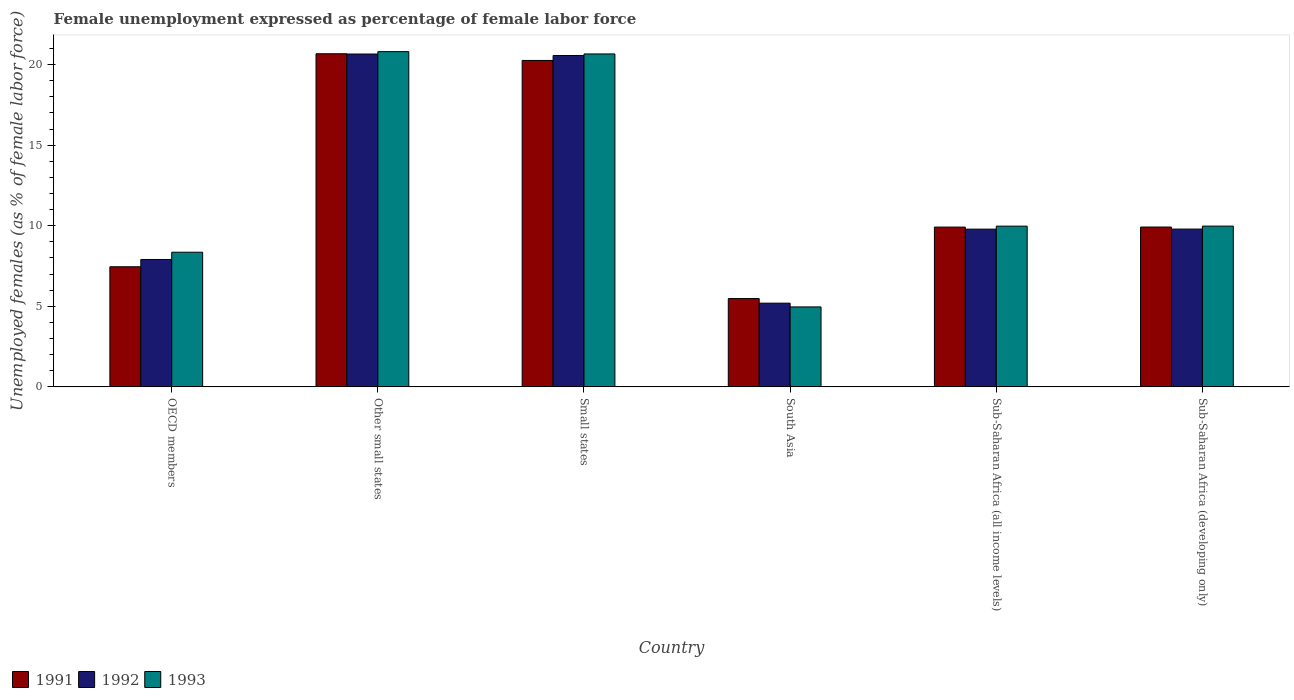How many different coloured bars are there?
Your answer should be very brief. 3. Are the number of bars on each tick of the X-axis equal?
Offer a terse response. Yes. How many bars are there on the 3rd tick from the left?
Provide a succinct answer. 3. How many bars are there on the 5th tick from the right?
Offer a terse response. 3. What is the label of the 4th group of bars from the left?
Ensure brevity in your answer.  South Asia. In how many cases, is the number of bars for a given country not equal to the number of legend labels?
Make the answer very short. 0. What is the unemployment in females in in 1991 in Sub-Saharan Africa (all income levels)?
Ensure brevity in your answer.  9.91. Across all countries, what is the maximum unemployment in females in in 1992?
Offer a terse response. 20.65. Across all countries, what is the minimum unemployment in females in in 1992?
Provide a short and direct response. 5.19. In which country was the unemployment in females in in 1992 maximum?
Your answer should be compact. Other small states. In which country was the unemployment in females in in 1993 minimum?
Provide a short and direct response. South Asia. What is the total unemployment in females in in 1992 in the graph?
Provide a succinct answer. 73.89. What is the difference between the unemployment in females in in 1993 in OECD members and that in Sub-Saharan Africa (developing only)?
Your response must be concise. -1.62. What is the difference between the unemployment in females in in 1992 in Small states and the unemployment in females in in 1993 in Sub-Saharan Africa (developing only)?
Offer a terse response. 10.58. What is the average unemployment in females in in 1991 per country?
Make the answer very short. 12.28. What is the difference between the unemployment in females in of/in 1991 and unemployment in females in of/in 1993 in Sub-Saharan Africa (all income levels)?
Offer a terse response. -0.06. What is the ratio of the unemployment in females in in 1991 in South Asia to that in Sub-Saharan Africa (developing only)?
Give a very brief answer. 0.55. What is the difference between the highest and the second highest unemployment in females in in 1992?
Your answer should be very brief. -10.86. What is the difference between the highest and the lowest unemployment in females in in 1991?
Ensure brevity in your answer.  15.19. In how many countries, is the unemployment in females in in 1991 greater than the average unemployment in females in in 1991 taken over all countries?
Keep it short and to the point. 2. What does the 1st bar from the right in OECD members represents?
Provide a short and direct response. 1993. Is it the case that in every country, the sum of the unemployment in females in in 1992 and unemployment in females in in 1993 is greater than the unemployment in females in in 1991?
Ensure brevity in your answer.  Yes. How many bars are there?
Give a very brief answer. 18. How many countries are there in the graph?
Ensure brevity in your answer.  6. Are the values on the major ticks of Y-axis written in scientific E-notation?
Make the answer very short. No. Does the graph contain any zero values?
Provide a short and direct response. No. Does the graph contain grids?
Provide a succinct answer. No. Where does the legend appear in the graph?
Keep it short and to the point. Bottom left. How many legend labels are there?
Offer a terse response. 3. How are the legend labels stacked?
Your answer should be very brief. Horizontal. What is the title of the graph?
Ensure brevity in your answer.  Female unemployment expressed as percentage of female labor force. What is the label or title of the X-axis?
Offer a terse response. Country. What is the label or title of the Y-axis?
Your response must be concise. Unemployed females (as % of female labor force). What is the Unemployed females (as % of female labor force) of 1991 in OECD members?
Offer a very short reply. 7.45. What is the Unemployed females (as % of female labor force) of 1992 in OECD members?
Make the answer very short. 7.9. What is the Unemployed females (as % of female labor force) in 1993 in OECD members?
Your answer should be compact. 8.35. What is the Unemployed females (as % of female labor force) of 1991 in Other small states?
Provide a short and direct response. 20.67. What is the Unemployed females (as % of female labor force) in 1992 in Other small states?
Make the answer very short. 20.65. What is the Unemployed females (as % of female labor force) in 1993 in Other small states?
Your answer should be compact. 20.8. What is the Unemployed females (as % of female labor force) of 1991 in Small states?
Ensure brevity in your answer.  20.25. What is the Unemployed females (as % of female labor force) in 1992 in Small states?
Keep it short and to the point. 20.56. What is the Unemployed females (as % of female labor force) in 1993 in Small states?
Your response must be concise. 20.66. What is the Unemployed females (as % of female labor force) in 1991 in South Asia?
Keep it short and to the point. 5.48. What is the Unemployed females (as % of female labor force) in 1992 in South Asia?
Your answer should be compact. 5.19. What is the Unemployed females (as % of female labor force) of 1993 in South Asia?
Your answer should be compact. 4.96. What is the Unemployed females (as % of female labor force) in 1991 in Sub-Saharan Africa (all income levels)?
Your response must be concise. 9.91. What is the Unemployed females (as % of female labor force) in 1992 in Sub-Saharan Africa (all income levels)?
Offer a terse response. 9.79. What is the Unemployed females (as % of female labor force) of 1993 in Sub-Saharan Africa (all income levels)?
Ensure brevity in your answer.  9.97. What is the Unemployed females (as % of female labor force) of 1991 in Sub-Saharan Africa (developing only)?
Make the answer very short. 9.92. What is the Unemployed females (as % of female labor force) in 1992 in Sub-Saharan Africa (developing only)?
Provide a succinct answer. 9.79. What is the Unemployed females (as % of female labor force) of 1993 in Sub-Saharan Africa (developing only)?
Keep it short and to the point. 9.98. Across all countries, what is the maximum Unemployed females (as % of female labor force) of 1991?
Provide a succinct answer. 20.67. Across all countries, what is the maximum Unemployed females (as % of female labor force) in 1992?
Give a very brief answer. 20.65. Across all countries, what is the maximum Unemployed females (as % of female labor force) of 1993?
Your answer should be compact. 20.8. Across all countries, what is the minimum Unemployed females (as % of female labor force) in 1991?
Offer a very short reply. 5.48. Across all countries, what is the minimum Unemployed females (as % of female labor force) of 1992?
Provide a succinct answer. 5.19. Across all countries, what is the minimum Unemployed females (as % of female labor force) in 1993?
Offer a very short reply. 4.96. What is the total Unemployed females (as % of female labor force) of 1991 in the graph?
Give a very brief answer. 73.69. What is the total Unemployed females (as % of female labor force) in 1992 in the graph?
Your answer should be compact. 73.89. What is the total Unemployed females (as % of female labor force) of 1993 in the graph?
Ensure brevity in your answer.  74.72. What is the difference between the Unemployed females (as % of female labor force) of 1991 in OECD members and that in Other small states?
Your response must be concise. -13.22. What is the difference between the Unemployed females (as % of female labor force) of 1992 in OECD members and that in Other small states?
Offer a very short reply. -12.75. What is the difference between the Unemployed females (as % of female labor force) in 1993 in OECD members and that in Other small states?
Your answer should be very brief. -12.45. What is the difference between the Unemployed females (as % of female labor force) of 1991 in OECD members and that in Small states?
Provide a succinct answer. -12.8. What is the difference between the Unemployed females (as % of female labor force) of 1992 in OECD members and that in Small states?
Your response must be concise. -12.66. What is the difference between the Unemployed females (as % of female labor force) in 1993 in OECD members and that in Small states?
Make the answer very short. -12.3. What is the difference between the Unemployed females (as % of female labor force) of 1991 in OECD members and that in South Asia?
Make the answer very short. 1.97. What is the difference between the Unemployed females (as % of female labor force) in 1992 in OECD members and that in South Asia?
Offer a very short reply. 2.71. What is the difference between the Unemployed females (as % of female labor force) in 1993 in OECD members and that in South Asia?
Your answer should be compact. 3.39. What is the difference between the Unemployed females (as % of female labor force) in 1991 in OECD members and that in Sub-Saharan Africa (all income levels)?
Your answer should be compact. -2.46. What is the difference between the Unemployed females (as % of female labor force) of 1992 in OECD members and that in Sub-Saharan Africa (all income levels)?
Give a very brief answer. -1.88. What is the difference between the Unemployed females (as % of female labor force) of 1993 in OECD members and that in Sub-Saharan Africa (all income levels)?
Offer a very short reply. -1.62. What is the difference between the Unemployed females (as % of female labor force) in 1991 in OECD members and that in Sub-Saharan Africa (developing only)?
Offer a very short reply. -2.47. What is the difference between the Unemployed females (as % of female labor force) in 1992 in OECD members and that in Sub-Saharan Africa (developing only)?
Make the answer very short. -1.89. What is the difference between the Unemployed females (as % of female labor force) in 1993 in OECD members and that in Sub-Saharan Africa (developing only)?
Offer a terse response. -1.62. What is the difference between the Unemployed females (as % of female labor force) of 1991 in Other small states and that in Small states?
Give a very brief answer. 0.41. What is the difference between the Unemployed females (as % of female labor force) in 1992 in Other small states and that in Small states?
Your answer should be very brief. 0.09. What is the difference between the Unemployed females (as % of female labor force) in 1993 in Other small states and that in Small states?
Provide a succinct answer. 0.14. What is the difference between the Unemployed females (as % of female labor force) in 1991 in Other small states and that in South Asia?
Make the answer very short. 15.19. What is the difference between the Unemployed females (as % of female labor force) of 1992 in Other small states and that in South Asia?
Offer a terse response. 15.46. What is the difference between the Unemployed females (as % of female labor force) of 1993 in Other small states and that in South Asia?
Ensure brevity in your answer.  15.84. What is the difference between the Unemployed females (as % of female labor force) of 1991 in Other small states and that in Sub-Saharan Africa (all income levels)?
Offer a very short reply. 10.75. What is the difference between the Unemployed females (as % of female labor force) of 1992 in Other small states and that in Sub-Saharan Africa (all income levels)?
Ensure brevity in your answer.  10.87. What is the difference between the Unemployed females (as % of female labor force) of 1993 in Other small states and that in Sub-Saharan Africa (all income levels)?
Offer a terse response. 10.83. What is the difference between the Unemployed females (as % of female labor force) in 1991 in Other small states and that in Sub-Saharan Africa (developing only)?
Offer a terse response. 10.75. What is the difference between the Unemployed females (as % of female labor force) of 1992 in Other small states and that in Sub-Saharan Africa (developing only)?
Give a very brief answer. 10.86. What is the difference between the Unemployed females (as % of female labor force) of 1993 in Other small states and that in Sub-Saharan Africa (developing only)?
Ensure brevity in your answer.  10.83. What is the difference between the Unemployed females (as % of female labor force) of 1991 in Small states and that in South Asia?
Offer a terse response. 14.77. What is the difference between the Unemployed females (as % of female labor force) in 1992 in Small states and that in South Asia?
Offer a terse response. 15.37. What is the difference between the Unemployed females (as % of female labor force) of 1993 in Small states and that in South Asia?
Your answer should be very brief. 15.7. What is the difference between the Unemployed females (as % of female labor force) in 1991 in Small states and that in Sub-Saharan Africa (all income levels)?
Provide a succinct answer. 10.34. What is the difference between the Unemployed females (as % of female labor force) of 1992 in Small states and that in Sub-Saharan Africa (all income levels)?
Offer a very short reply. 10.77. What is the difference between the Unemployed females (as % of female labor force) of 1993 in Small states and that in Sub-Saharan Africa (all income levels)?
Provide a short and direct response. 10.69. What is the difference between the Unemployed females (as % of female labor force) in 1991 in Small states and that in Sub-Saharan Africa (developing only)?
Keep it short and to the point. 10.34. What is the difference between the Unemployed females (as % of female labor force) of 1992 in Small states and that in Sub-Saharan Africa (developing only)?
Your answer should be compact. 10.77. What is the difference between the Unemployed females (as % of female labor force) of 1993 in Small states and that in Sub-Saharan Africa (developing only)?
Offer a terse response. 10.68. What is the difference between the Unemployed females (as % of female labor force) of 1991 in South Asia and that in Sub-Saharan Africa (all income levels)?
Provide a short and direct response. -4.43. What is the difference between the Unemployed females (as % of female labor force) of 1992 in South Asia and that in Sub-Saharan Africa (all income levels)?
Your answer should be very brief. -4.59. What is the difference between the Unemployed females (as % of female labor force) in 1993 in South Asia and that in Sub-Saharan Africa (all income levels)?
Your response must be concise. -5.01. What is the difference between the Unemployed females (as % of female labor force) of 1991 in South Asia and that in Sub-Saharan Africa (developing only)?
Offer a terse response. -4.44. What is the difference between the Unemployed females (as % of female labor force) in 1992 in South Asia and that in Sub-Saharan Africa (developing only)?
Your answer should be compact. -4.6. What is the difference between the Unemployed females (as % of female labor force) of 1993 in South Asia and that in Sub-Saharan Africa (developing only)?
Give a very brief answer. -5.01. What is the difference between the Unemployed females (as % of female labor force) in 1991 in Sub-Saharan Africa (all income levels) and that in Sub-Saharan Africa (developing only)?
Your answer should be very brief. -0. What is the difference between the Unemployed females (as % of female labor force) of 1992 in Sub-Saharan Africa (all income levels) and that in Sub-Saharan Africa (developing only)?
Keep it short and to the point. -0. What is the difference between the Unemployed females (as % of female labor force) of 1993 in Sub-Saharan Africa (all income levels) and that in Sub-Saharan Africa (developing only)?
Give a very brief answer. -0. What is the difference between the Unemployed females (as % of female labor force) in 1991 in OECD members and the Unemployed females (as % of female labor force) in 1992 in Other small states?
Ensure brevity in your answer.  -13.2. What is the difference between the Unemployed females (as % of female labor force) in 1991 in OECD members and the Unemployed females (as % of female labor force) in 1993 in Other small states?
Offer a terse response. -13.35. What is the difference between the Unemployed females (as % of female labor force) of 1992 in OECD members and the Unemployed females (as % of female labor force) of 1993 in Other small states?
Offer a terse response. -12.9. What is the difference between the Unemployed females (as % of female labor force) of 1991 in OECD members and the Unemployed females (as % of female labor force) of 1992 in Small states?
Provide a succinct answer. -13.11. What is the difference between the Unemployed females (as % of female labor force) in 1991 in OECD members and the Unemployed females (as % of female labor force) in 1993 in Small states?
Provide a short and direct response. -13.21. What is the difference between the Unemployed females (as % of female labor force) in 1992 in OECD members and the Unemployed females (as % of female labor force) in 1993 in Small states?
Ensure brevity in your answer.  -12.75. What is the difference between the Unemployed females (as % of female labor force) in 1991 in OECD members and the Unemployed females (as % of female labor force) in 1992 in South Asia?
Offer a very short reply. 2.26. What is the difference between the Unemployed females (as % of female labor force) of 1991 in OECD members and the Unemployed females (as % of female labor force) of 1993 in South Asia?
Provide a succinct answer. 2.49. What is the difference between the Unemployed females (as % of female labor force) of 1992 in OECD members and the Unemployed females (as % of female labor force) of 1993 in South Asia?
Your answer should be compact. 2.94. What is the difference between the Unemployed females (as % of female labor force) in 1991 in OECD members and the Unemployed females (as % of female labor force) in 1992 in Sub-Saharan Africa (all income levels)?
Provide a short and direct response. -2.34. What is the difference between the Unemployed females (as % of female labor force) in 1991 in OECD members and the Unemployed females (as % of female labor force) in 1993 in Sub-Saharan Africa (all income levels)?
Offer a terse response. -2.52. What is the difference between the Unemployed females (as % of female labor force) in 1992 in OECD members and the Unemployed females (as % of female labor force) in 1993 in Sub-Saharan Africa (all income levels)?
Your answer should be very brief. -2.07. What is the difference between the Unemployed females (as % of female labor force) of 1991 in OECD members and the Unemployed females (as % of female labor force) of 1992 in Sub-Saharan Africa (developing only)?
Keep it short and to the point. -2.34. What is the difference between the Unemployed females (as % of female labor force) of 1991 in OECD members and the Unemployed females (as % of female labor force) of 1993 in Sub-Saharan Africa (developing only)?
Give a very brief answer. -2.52. What is the difference between the Unemployed females (as % of female labor force) in 1992 in OECD members and the Unemployed females (as % of female labor force) in 1993 in Sub-Saharan Africa (developing only)?
Provide a succinct answer. -2.07. What is the difference between the Unemployed females (as % of female labor force) of 1991 in Other small states and the Unemployed females (as % of female labor force) of 1992 in Small states?
Ensure brevity in your answer.  0.11. What is the difference between the Unemployed females (as % of female labor force) in 1991 in Other small states and the Unemployed females (as % of female labor force) in 1993 in Small states?
Ensure brevity in your answer.  0.01. What is the difference between the Unemployed females (as % of female labor force) of 1992 in Other small states and the Unemployed females (as % of female labor force) of 1993 in Small states?
Provide a succinct answer. -0.01. What is the difference between the Unemployed females (as % of female labor force) of 1991 in Other small states and the Unemployed females (as % of female labor force) of 1992 in South Asia?
Ensure brevity in your answer.  15.47. What is the difference between the Unemployed females (as % of female labor force) in 1991 in Other small states and the Unemployed females (as % of female labor force) in 1993 in South Asia?
Provide a succinct answer. 15.71. What is the difference between the Unemployed females (as % of female labor force) in 1992 in Other small states and the Unemployed females (as % of female labor force) in 1993 in South Asia?
Give a very brief answer. 15.69. What is the difference between the Unemployed females (as % of female labor force) in 1991 in Other small states and the Unemployed females (as % of female labor force) in 1992 in Sub-Saharan Africa (all income levels)?
Make the answer very short. 10.88. What is the difference between the Unemployed females (as % of female labor force) in 1991 in Other small states and the Unemployed females (as % of female labor force) in 1993 in Sub-Saharan Africa (all income levels)?
Your answer should be compact. 10.7. What is the difference between the Unemployed females (as % of female labor force) of 1992 in Other small states and the Unemployed females (as % of female labor force) of 1993 in Sub-Saharan Africa (all income levels)?
Your answer should be compact. 10.68. What is the difference between the Unemployed females (as % of female labor force) in 1991 in Other small states and the Unemployed females (as % of female labor force) in 1992 in Sub-Saharan Africa (developing only)?
Make the answer very short. 10.88. What is the difference between the Unemployed females (as % of female labor force) of 1991 in Other small states and the Unemployed females (as % of female labor force) of 1993 in Sub-Saharan Africa (developing only)?
Keep it short and to the point. 10.69. What is the difference between the Unemployed females (as % of female labor force) in 1992 in Other small states and the Unemployed females (as % of female labor force) in 1993 in Sub-Saharan Africa (developing only)?
Keep it short and to the point. 10.68. What is the difference between the Unemployed females (as % of female labor force) of 1991 in Small states and the Unemployed females (as % of female labor force) of 1992 in South Asia?
Your answer should be compact. 15.06. What is the difference between the Unemployed females (as % of female labor force) of 1991 in Small states and the Unemployed females (as % of female labor force) of 1993 in South Asia?
Give a very brief answer. 15.29. What is the difference between the Unemployed females (as % of female labor force) of 1992 in Small states and the Unemployed females (as % of female labor force) of 1993 in South Asia?
Make the answer very short. 15.6. What is the difference between the Unemployed females (as % of female labor force) of 1991 in Small states and the Unemployed females (as % of female labor force) of 1992 in Sub-Saharan Africa (all income levels)?
Your answer should be compact. 10.47. What is the difference between the Unemployed females (as % of female labor force) of 1991 in Small states and the Unemployed females (as % of female labor force) of 1993 in Sub-Saharan Africa (all income levels)?
Your answer should be compact. 10.28. What is the difference between the Unemployed females (as % of female labor force) of 1992 in Small states and the Unemployed females (as % of female labor force) of 1993 in Sub-Saharan Africa (all income levels)?
Your answer should be compact. 10.59. What is the difference between the Unemployed females (as % of female labor force) of 1991 in Small states and the Unemployed females (as % of female labor force) of 1992 in Sub-Saharan Africa (developing only)?
Provide a succinct answer. 10.46. What is the difference between the Unemployed females (as % of female labor force) of 1991 in Small states and the Unemployed females (as % of female labor force) of 1993 in Sub-Saharan Africa (developing only)?
Give a very brief answer. 10.28. What is the difference between the Unemployed females (as % of female labor force) in 1992 in Small states and the Unemployed females (as % of female labor force) in 1993 in Sub-Saharan Africa (developing only)?
Offer a terse response. 10.58. What is the difference between the Unemployed females (as % of female labor force) of 1991 in South Asia and the Unemployed females (as % of female labor force) of 1992 in Sub-Saharan Africa (all income levels)?
Keep it short and to the point. -4.31. What is the difference between the Unemployed females (as % of female labor force) of 1991 in South Asia and the Unemployed females (as % of female labor force) of 1993 in Sub-Saharan Africa (all income levels)?
Offer a terse response. -4.49. What is the difference between the Unemployed females (as % of female labor force) in 1992 in South Asia and the Unemployed females (as % of female labor force) in 1993 in Sub-Saharan Africa (all income levels)?
Provide a succinct answer. -4.78. What is the difference between the Unemployed females (as % of female labor force) of 1991 in South Asia and the Unemployed females (as % of female labor force) of 1992 in Sub-Saharan Africa (developing only)?
Your answer should be very brief. -4.31. What is the difference between the Unemployed females (as % of female labor force) in 1991 in South Asia and the Unemployed females (as % of female labor force) in 1993 in Sub-Saharan Africa (developing only)?
Ensure brevity in your answer.  -4.5. What is the difference between the Unemployed females (as % of female labor force) of 1992 in South Asia and the Unemployed females (as % of female labor force) of 1993 in Sub-Saharan Africa (developing only)?
Offer a terse response. -4.78. What is the difference between the Unemployed females (as % of female labor force) of 1991 in Sub-Saharan Africa (all income levels) and the Unemployed females (as % of female labor force) of 1992 in Sub-Saharan Africa (developing only)?
Provide a short and direct response. 0.12. What is the difference between the Unemployed females (as % of female labor force) in 1991 in Sub-Saharan Africa (all income levels) and the Unemployed females (as % of female labor force) in 1993 in Sub-Saharan Africa (developing only)?
Keep it short and to the point. -0.06. What is the difference between the Unemployed females (as % of female labor force) of 1992 in Sub-Saharan Africa (all income levels) and the Unemployed females (as % of female labor force) of 1993 in Sub-Saharan Africa (developing only)?
Your answer should be very brief. -0.19. What is the average Unemployed females (as % of female labor force) of 1991 per country?
Your response must be concise. 12.28. What is the average Unemployed females (as % of female labor force) in 1992 per country?
Give a very brief answer. 12.31. What is the average Unemployed females (as % of female labor force) of 1993 per country?
Your answer should be compact. 12.45. What is the difference between the Unemployed females (as % of female labor force) of 1991 and Unemployed females (as % of female labor force) of 1992 in OECD members?
Provide a short and direct response. -0.45. What is the difference between the Unemployed females (as % of female labor force) of 1991 and Unemployed females (as % of female labor force) of 1993 in OECD members?
Offer a very short reply. -0.9. What is the difference between the Unemployed females (as % of female labor force) in 1992 and Unemployed females (as % of female labor force) in 1993 in OECD members?
Offer a terse response. -0.45. What is the difference between the Unemployed females (as % of female labor force) of 1991 and Unemployed females (as % of female labor force) of 1992 in Other small states?
Offer a terse response. 0.02. What is the difference between the Unemployed females (as % of female labor force) of 1991 and Unemployed females (as % of female labor force) of 1993 in Other small states?
Ensure brevity in your answer.  -0.13. What is the difference between the Unemployed females (as % of female labor force) of 1992 and Unemployed females (as % of female labor force) of 1993 in Other small states?
Give a very brief answer. -0.15. What is the difference between the Unemployed females (as % of female labor force) of 1991 and Unemployed females (as % of female labor force) of 1992 in Small states?
Make the answer very short. -0.31. What is the difference between the Unemployed females (as % of female labor force) in 1991 and Unemployed females (as % of female labor force) in 1993 in Small states?
Make the answer very short. -0.4. What is the difference between the Unemployed females (as % of female labor force) of 1992 and Unemployed females (as % of female labor force) of 1993 in Small states?
Offer a very short reply. -0.1. What is the difference between the Unemployed females (as % of female labor force) in 1991 and Unemployed females (as % of female labor force) in 1992 in South Asia?
Your answer should be compact. 0.29. What is the difference between the Unemployed females (as % of female labor force) of 1991 and Unemployed females (as % of female labor force) of 1993 in South Asia?
Give a very brief answer. 0.52. What is the difference between the Unemployed females (as % of female labor force) of 1992 and Unemployed females (as % of female labor force) of 1993 in South Asia?
Keep it short and to the point. 0.23. What is the difference between the Unemployed females (as % of female labor force) of 1991 and Unemployed females (as % of female labor force) of 1992 in Sub-Saharan Africa (all income levels)?
Provide a short and direct response. 0.13. What is the difference between the Unemployed females (as % of female labor force) of 1991 and Unemployed females (as % of female labor force) of 1993 in Sub-Saharan Africa (all income levels)?
Offer a very short reply. -0.06. What is the difference between the Unemployed females (as % of female labor force) in 1992 and Unemployed females (as % of female labor force) in 1993 in Sub-Saharan Africa (all income levels)?
Keep it short and to the point. -0.18. What is the difference between the Unemployed females (as % of female labor force) in 1991 and Unemployed females (as % of female labor force) in 1992 in Sub-Saharan Africa (developing only)?
Your answer should be compact. 0.13. What is the difference between the Unemployed females (as % of female labor force) of 1991 and Unemployed females (as % of female labor force) of 1993 in Sub-Saharan Africa (developing only)?
Your answer should be very brief. -0.06. What is the difference between the Unemployed females (as % of female labor force) of 1992 and Unemployed females (as % of female labor force) of 1993 in Sub-Saharan Africa (developing only)?
Provide a succinct answer. -0.18. What is the ratio of the Unemployed females (as % of female labor force) of 1991 in OECD members to that in Other small states?
Your answer should be very brief. 0.36. What is the ratio of the Unemployed females (as % of female labor force) of 1992 in OECD members to that in Other small states?
Make the answer very short. 0.38. What is the ratio of the Unemployed females (as % of female labor force) in 1993 in OECD members to that in Other small states?
Keep it short and to the point. 0.4. What is the ratio of the Unemployed females (as % of female labor force) in 1991 in OECD members to that in Small states?
Keep it short and to the point. 0.37. What is the ratio of the Unemployed females (as % of female labor force) of 1992 in OECD members to that in Small states?
Provide a short and direct response. 0.38. What is the ratio of the Unemployed females (as % of female labor force) in 1993 in OECD members to that in Small states?
Make the answer very short. 0.4. What is the ratio of the Unemployed females (as % of female labor force) of 1991 in OECD members to that in South Asia?
Keep it short and to the point. 1.36. What is the ratio of the Unemployed females (as % of female labor force) of 1992 in OECD members to that in South Asia?
Give a very brief answer. 1.52. What is the ratio of the Unemployed females (as % of female labor force) of 1993 in OECD members to that in South Asia?
Provide a succinct answer. 1.68. What is the ratio of the Unemployed females (as % of female labor force) of 1991 in OECD members to that in Sub-Saharan Africa (all income levels)?
Provide a succinct answer. 0.75. What is the ratio of the Unemployed females (as % of female labor force) of 1992 in OECD members to that in Sub-Saharan Africa (all income levels)?
Keep it short and to the point. 0.81. What is the ratio of the Unemployed females (as % of female labor force) in 1993 in OECD members to that in Sub-Saharan Africa (all income levels)?
Your answer should be very brief. 0.84. What is the ratio of the Unemployed females (as % of female labor force) in 1991 in OECD members to that in Sub-Saharan Africa (developing only)?
Keep it short and to the point. 0.75. What is the ratio of the Unemployed females (as % of female labor force) in 1992 in OECD members to that in Sub-Saharan Africa (developing only)?
Your response must be concise. 0.81. What is the ratio of the Unemployed females (as % of female labor force) in 1993 in OECD members to that in Sub-Saharan Africa (developing only)?
Offer a very short reply. 0.84. What is the ratio of the Unemployed females (as % of female labor force) in 1991 in Other small states to that in Small states?
Offer a very short reply. 1.02. What is the ratio of the Unemployed females (as % of female labor force) in 1993 in Other small states to that in Small states?
Provide a succinct answer. 1.01. What is the ratio of the Unemployed females (as % of female labor force) of 1991 in Other small states to that in South Asia?
Offer a terse response. 3.77. What is the ratio of the Unemployed females (as % of female labor force) of 1992 in Other small states to that in South Asia?
Provide a short and direct response. 3.98. What is the ratio of the Unemployed females (as % of female labor force) of 1993 in Other small states to that in South Asia?
Keep it short and to the point. 4.19. What is the ratio of the Unemployed females (as % of female labor force) in 1991 in Other small states to that in Sub-Saharan Africa (all income levels)?
Ensure brevity in your answer.  2.08. What is the ratio of the Unemployed females (as % of female labor force) in 1992 in Other small states to that in Sub-Saharan Africa (all income levels)?
Give a very brief answer. 2.11. What is the ratio of the Unemployed females (as % of female labor force) in 1993 in Other small states to that in Sub-Saharan Africa (all income levels)?
Offer a terse response. 2.09. What is the ratio of the Unemployed females (as % of female labor force) in 1991 in Other small states to that in Sub-Saharan Africa (developing only)?
Offer a terse response. 2.08. What is the ratio of the Unemployed females (as % of female labor force) in 1992 in Other small states to that in Sub-Saharan Africa (developing only)?
Provide a short and direct response. 2.11. What is the ratio of the Unemployed females (as % of female labor force) of 1993 in Other small states to that in Sub-Saharan Africa (developing only)?
Provide a succinct answer. 2.09. What is the ratio of the Unemployed females (as % of female labor force) of 1991 in Small states to that in South Asia?
Offer a very short reply. 3.7. What is the ratio of the Unemployed females (as % of female labor force) in 1992 in Small states to that in South Asia?
Your answer should be compact. 3.96. What is the ratio of the Unemployed females (as % of female labor force) of 1993 in Small states to that in South Asia?
Make the answer very short. 4.16. What is the ratio of the Unemployed females (as % of female labor force) of 1991 in Small states to that in Sub-Saharan Africa (all income levels)?
Make the answer very short. 2.04. What is the ratio of the Unemployed females (as % of female labor force) of 1992 in Small states to that in Sub-Saharan Africa (all income levels)?
Ensure brevity in your answer.  2.1. What is the ratio of the Unemployed females (as % of female labor force) of 1993 in Small states to that in Sub-Saharan Africa (all income levels)?
Give a very brief answer. 2.07. What is the ratio of the Unemployed females (as % of female labor force) in 1991 in Small states to that in Sub-Saharan Africa (developing only)?
Ensure brevity in your answer.  2.04. What is the ratio of the Unemployed females (as % of female labor force) of 1992 in Small states to that in Sub-Saharan Africa (developing only)?
Offer a terse response. 2.1. What is the ratio of the Unemployed females (as % of female labor force) in 1993 in Small states to that in Sub-Saharan Africa (developing only)?
Provide a succinct answer. 2.07. What is the ratio of the Unemployed females (as % of female labor force) of 1991 in South Asia to that in Sub-Saharan Africa (all income levels)?
Provide a succinct answer. 0.55. What is the ratio of the Unemployed females (as % of female labor force) of 1992 in South Asia to that in Sub-Saharan Africa (all income levels)?
Ensure brevity in your answer.  0.53. What is the ratio of the Unemployed females (as % of female labor force) of 1993 in South Asia to that in Sub-Saharan Africa (all income levels)?
Provide a succinct answer. 0.5. What is the ratio of the Unemployed females (as % of female labor force) in 1991 in South Asia to that in Sub-Saharan Africa (developing only)?
Offer a very short reply. 0.55. What is the ratio of the Unemployed females (as % of female labor force) of 1992 in South Asia to that in Sub-Saharan Africa (developing only)?
Ensure brevity in your answer.  0.53. What is the ratio of the Unemployed females (as % of female labor force) in 1993 in South Asia to that in Sub-Saharan Africa (developing only)?
Your answer should be compact. 0.5. What is the difference between the highest and the second highest Unemployed females (as % of female labor force) of 1991?
Ensure brevity in your answer.  0.41. What is the difference between the highest and the second highest Unemployed females (as % of female labor force) of 1992?
Offer a very short reply. 0.09. What is the difference between the highest and the second highest Unemployed females (as % of female labor force) in 1993?
Provide a short and direct response. 0.14. What is the difference between the highest and the lowest Unemployed females (as % of female labor force) of 1991?
Make the answer very short. 15.19. What is the difference between the highest and the lowest Unemployed females (as % of female labor force) of 1992?
Provide a succinct answer. 15.46. What is the difference between the highest and the lowest Unemployed females (as % of female labor force) of 1993?
Provide a short and direct response. 15.84. 